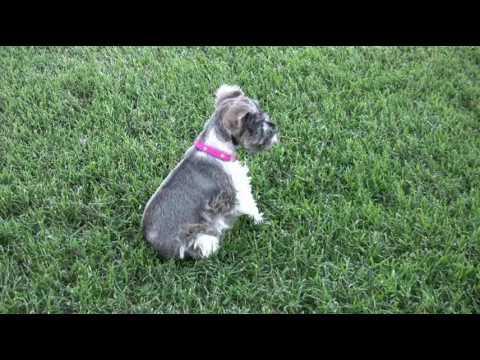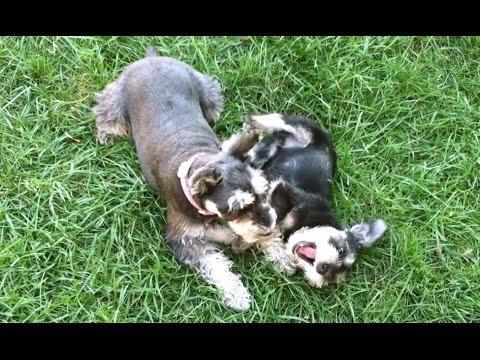The first image is the image on the left, the second image is the image on the right. Evaluate the accuracy of this statement regarding the images: "There is exactly one dog holding a toy in its mouth.". Is it true? Answer yes or no. No. The first image is the image on the left, the second image is the image on the right. Given the left and right images, does the statement "The left image shows a grayer dog to the left of a whiter dog, and the right image shows at least one schnauzer with something held in its mouth." hold true? Answer yes or no. No. 